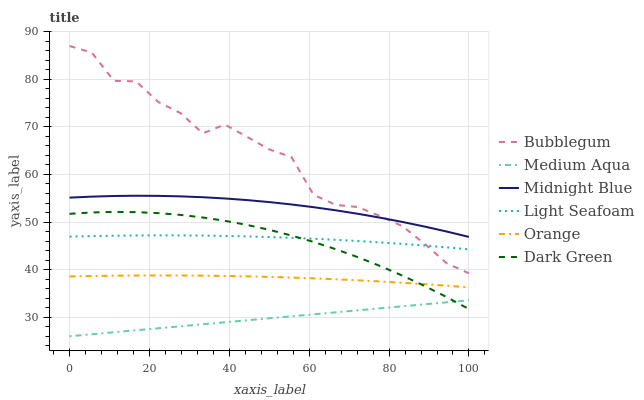Does Medium Aqua have the minimum area under the curve?
Answer yes or no. Yes. Does Bubblegum have the maximum area under the curve?
Answer yes or no. Yes. Does Bubblegum have the minimum area under the curve?
Answer yes or no. No. Does Medium Aqua have the maximum area under the curve?
Answer yes or no. No. Is Medium Aqua the smoothest?
Answer yes or no. Yes. Is Bubblegum the roughest?
Answer yes or no. Yes. Is Bubblegum the smoothest?
Answer yes or no. No. Is Medium Aqua the roughest?
Answer yes or no. No. Does Medium Aqua have the lowest value?
Answer yes or no. Yes. Does Bubblegum have the lowest value?
Answer yes or no. No. Does Bubblegum have the highest value?
Answer yes or no. Yes. Does Medium Aqua have the highest value?
Answer yes or no. No. Is Medium Aqua less than Bubblegum?
Answer yes or no. Yes. Is Light Seafoam greater than Orange?
Answer yes or no. Yes. Does Orange intersect Dark Green?
Answer yes or no. Yes. Is Orange less than Dark Green?
Answer yes or no. No. Is Orange greater than Dark Green?
Answer yes or no. No. Does Medium Aqua intersect Bubblegum?
Answer yes or no. No. 